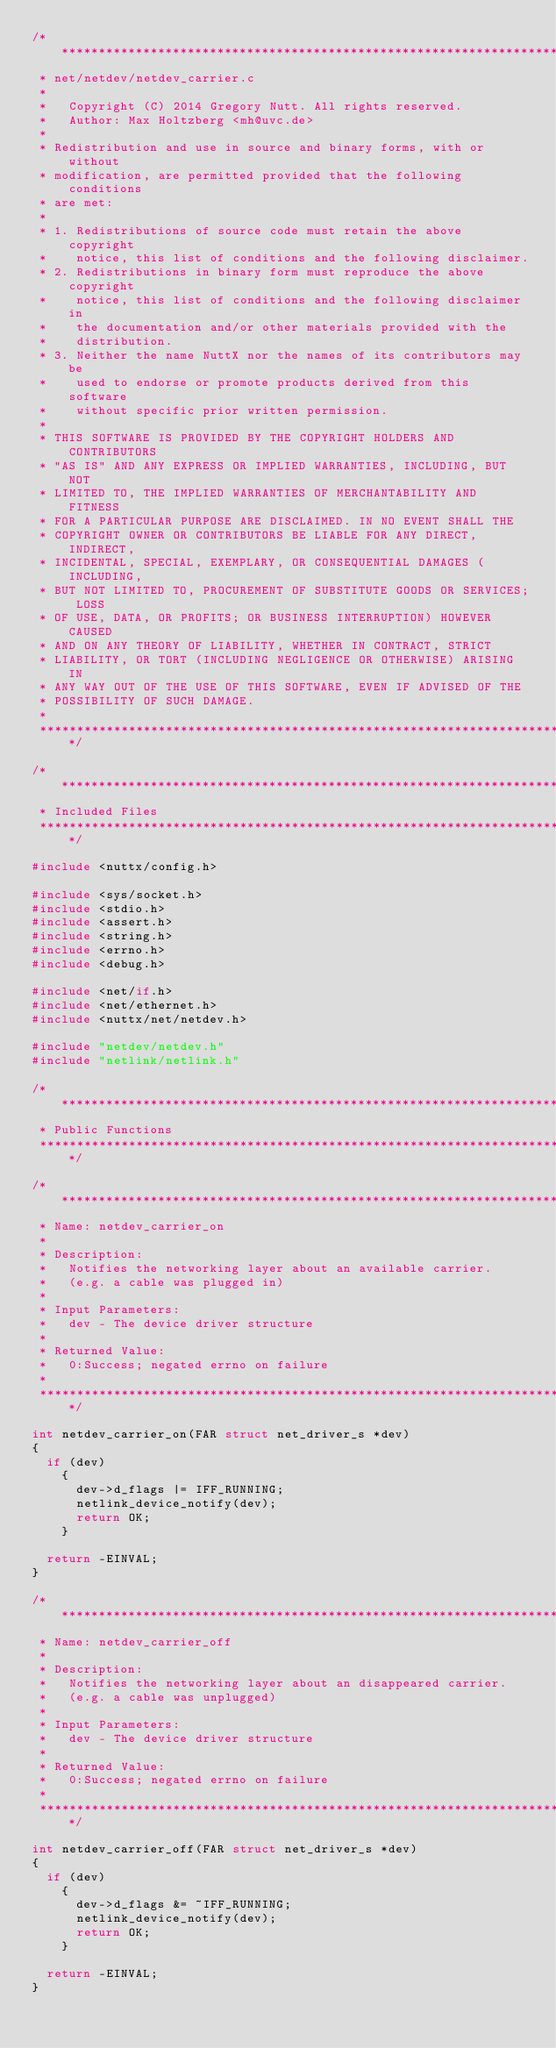Convert code to text. <code><loc_0><loc_0><loc_500><loc_500><_C_>/****************************************************************************
 * net/netdev/netdev_carrier.c
 *
 *   Copyright (C) 2014 Gregory Nutt. All rights reserved.
 *   Author: Max Holtzberg <mh@uvc.de>
 *
 * Redistribution and use in source and binary forms, with or without
 * modification, are permitted provided that the following conditions
 * are met:
 *
 * 1. Redistributions of source code must retain the above copyright
 *    notice, this list of conditions and the following disclaimer.
 * 2. Redistributions in binary form must reproduce the above copyright
 *    notice, this list of conditions and the following disclaimer in
 *    the documentation and/or other materials provided with the
 *    distribution.
 * 3. Neither the name NuttX nor the names of its contributors may be
 *    used to endorse or promote products derived from this software
 *    without specific prior written permission.
 *
 * THIS SOFTWARE IS PROVIDED BY THE COPYRIGHT HOLDERS AND CONTRIBUTORS
 * "AS IS" AND ANY EXPRESS OR IMPLIED WARRANTIES, INCLUDING, BUT NOT
 * LIMITED TO, THE IMPLIED WARRANTIES OF MERCHANTABILITY AND FITNESS
 * FOR A PARTICULAR PURPOSE ARE DISCLAIMED. IN NO EVENT SHALL THE
 * COPYRIGHT OWNER OR CONTRIBUTORS BE LIABLE FOR ANY DIRECT, INDIRECT,
 * INCIDENTAL, SPECIAL, EXEMPLARY, OR CONSEQUENTIAL DAMAGES (INCLUDING,
 * BUT NOT LIMITED TO, PROCUREMENT OF SUBSTITUTE GOODS OR SERVICES; LOSS
 * OF USE, DATA, OR PROFITS; OR BUSINESS INTERRUPTION) HOWEVER CAUSED
 * AND ON ANY THEORY OF LIABILITY, WHETHER IN CONTRACT, STRICT
 * LIABILITY, OR TORT (INCLUDING NEGLIGENCE OR OTHERWISE) ARISING IN
 * ANY WAY OUT OF THE USE OF THIS SOFTWARE, EVEN IF ADVISED OF THE
 * POSSIBILITY OF SUCH DAMAGE.
 *
 ****************************************************************************/

/****************************************************************************
 * Included Files
 ****************************************************************************/

#include <nuttx/config.h>

#include <sys/socket.h>
#include <stdio.h>
#include <assert.h>
#include <string.h>
#include <errno.h>
#include <debug.h>

#include <net/if.h>
#include <net/ethernet.h>
#include <nuttx/net/netdev.h>

#include "netdev/netdev.h"
#include "netlink/netlink.h"

/****************************************************************************
 * Public Functions
 ****************************************************************************/

/****************************************************************************
 * Name: netdev_carrier_on
 *
 * Description:
 *   Notifies the networking layer about an available carrier.
 *   (e.g. a cable was plugged in)
 *
 * Input Parameters:
 *   dev - The device driver structure
 *
 * Returned Value:
 *   0:Success; negated errno on failure
 *
 ****************************************************************************/

int netdev_carrier_on(FAR struct net_driver_s *dev)
{
  if (dev)
    {
      dev->d_flags |= IFF_RUNNING;
      netlink_device_notify(dev);
      return OK;
    }

  return -EINVAL;
}

/****************************************************************************
 * Name: netdev_carrier_off
 *
 * Description:
 *   Notifies the networking layer about an disappeared carrier.
 *   (e.g. a cable was unplugged)
 *
 * Input Parameters:
 *   dev - The device driver structure
 *
 * Returned Value:
 *   0:Success; negated errno on failure
 *
 ****************************************************************************/

int netdev_carrier_off(FAR struct net_driver_s *dev)
{
  if (dev)
    {
      dev->d_flags &= ~IFF_RUNNING;
      netlink_device_notify(dev);
      return OK;
    }

  return -EINVAL;
}
</code> 